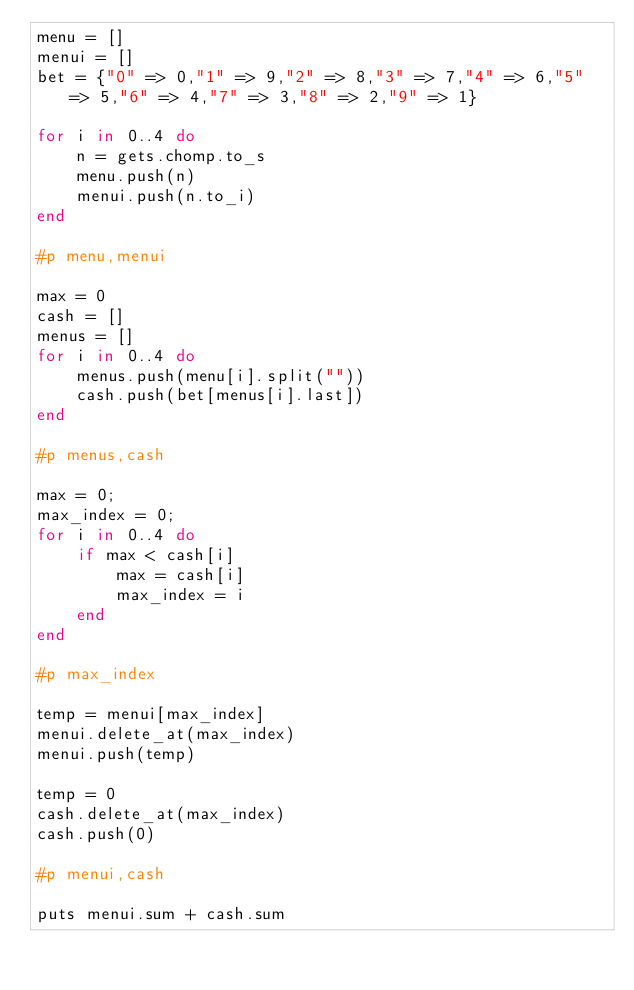Convert code to text. <code><loc_0><loc_0><loc_500><loc_500><_Ruby_>menu = []
menui = []
bet = {"0" => 0,"1" => 9,"2" => 8,"3" => 7,"4" => 6,"5" => 5,"6" => 4,"7" => 3,"8" => 2,"9" => 1}

for i in 0..4 do
    n = gets.chomp.to_s
    menu.push(n)
    menui.push(n.to_i)
end

#p menu,menui

max = 0
cash = []
menus = []
for i in 0..4 do
    menus.push(menu[i].split(""))
    cash.push(bet[menus[i].last])
end

#p menus,cash

max = 0;
max_index = 0;
for i in 0..4 do
    if max < cash[i]
        max = cash[i]
        max_index = i
    end
end

#p max_index

temp = menui[max_index]
menui.delete_at(max_index)
menui.push(temp)

temp = 0
cash.delete_at(max_index)
cash.push(0)

#p menui,cash

puts menui.sum + cash.sum</code> 